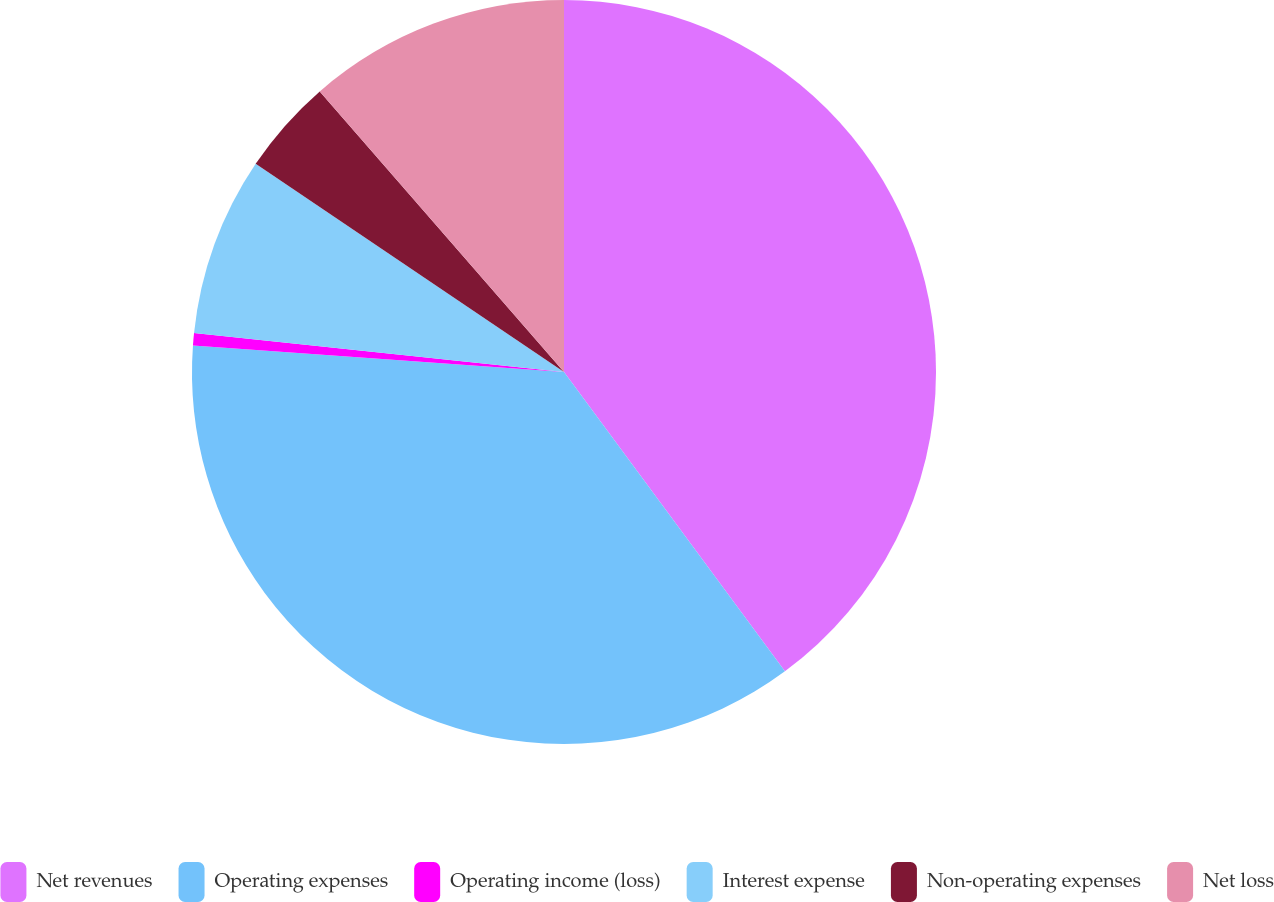<chart> <loc_0><loc_0><loc_500><loc_500><pie_chart><fcel>Net revenues<fcel>Operating expenses<fcel>Operating income (loss)<fcel>Interest expense<fcel>Non-operating expenses<fcel>Net loss<nl><fcel>39.88%<fcel>36.26%<fcel>0.53%<fcel>7.78%<fcel>4.15%<fcel>11.4%<nl></chart> 